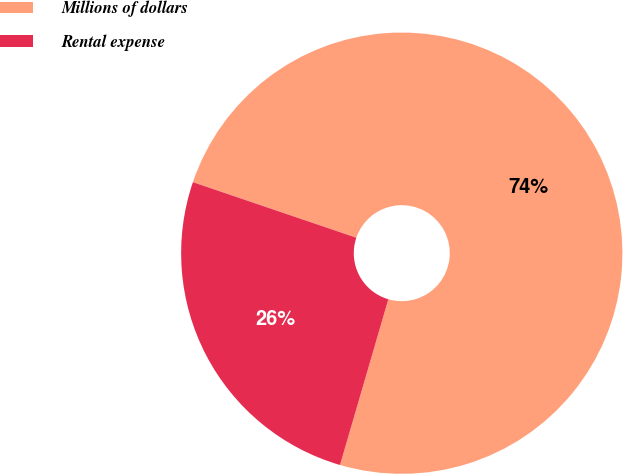Convert chart. <chart><loc_0><loc_0><loc_500><loc_500><pie_chart><fcel>Millions of dollars<fcel>Rental expense<nl><fcel>74.3%<fcel>25.7%<nl></chart> 